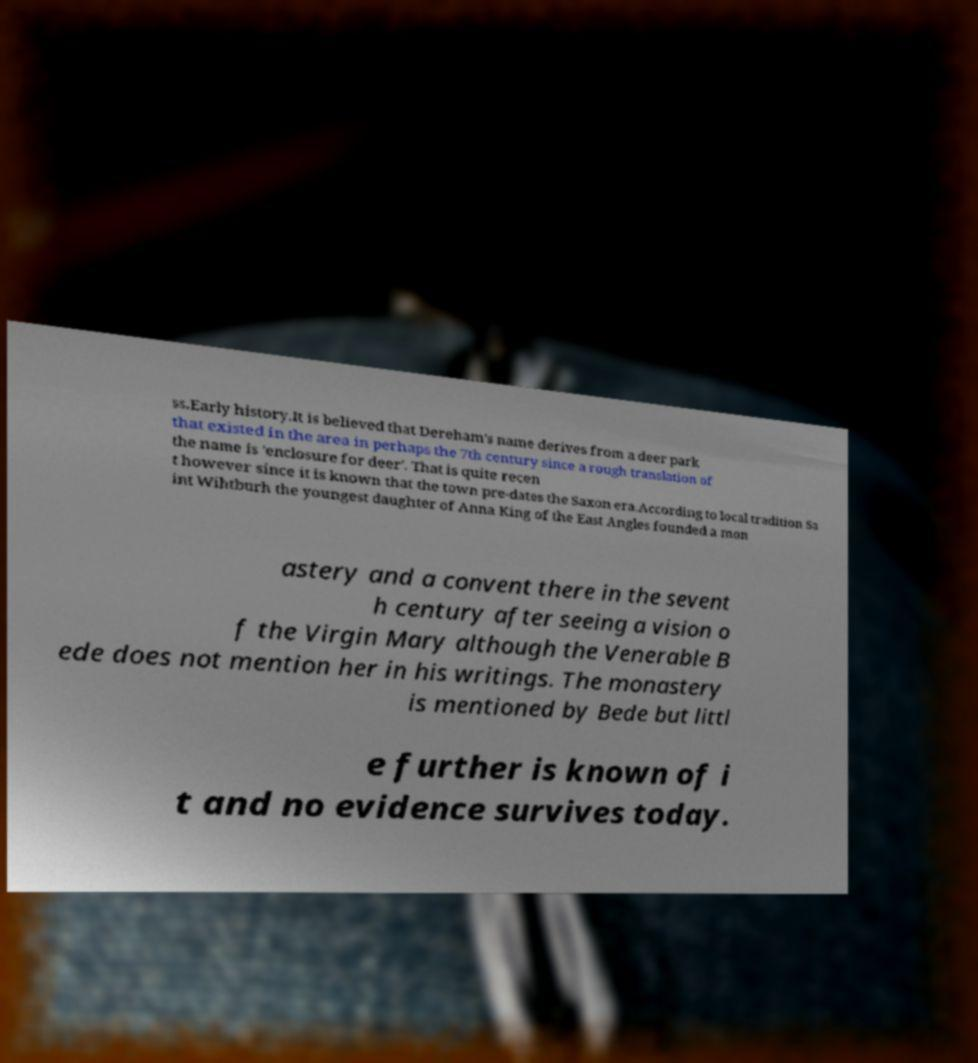What messages or text are displayed in this image? I need them in a readable, typed format. ss.Early history.It is believed that Dereham's name derives from a deer park that existed in the area in perhaps the 7th century since a rough translation of the name is 'enclosure for deer'. That is quite recen t however since it is known that the town pre-dates the Saxon era.According to local tradition Sa int Wihtburh the youngest daughter of Anna King of the East Angles founded a mon astery and a convent there in the sevent h century after seeing a vision o f the Virgin Mary although the Venerable B ede does not mention her in his writings. The monastery is mentioned by Bede but littl e further is known of i t and no evidence survives today. 